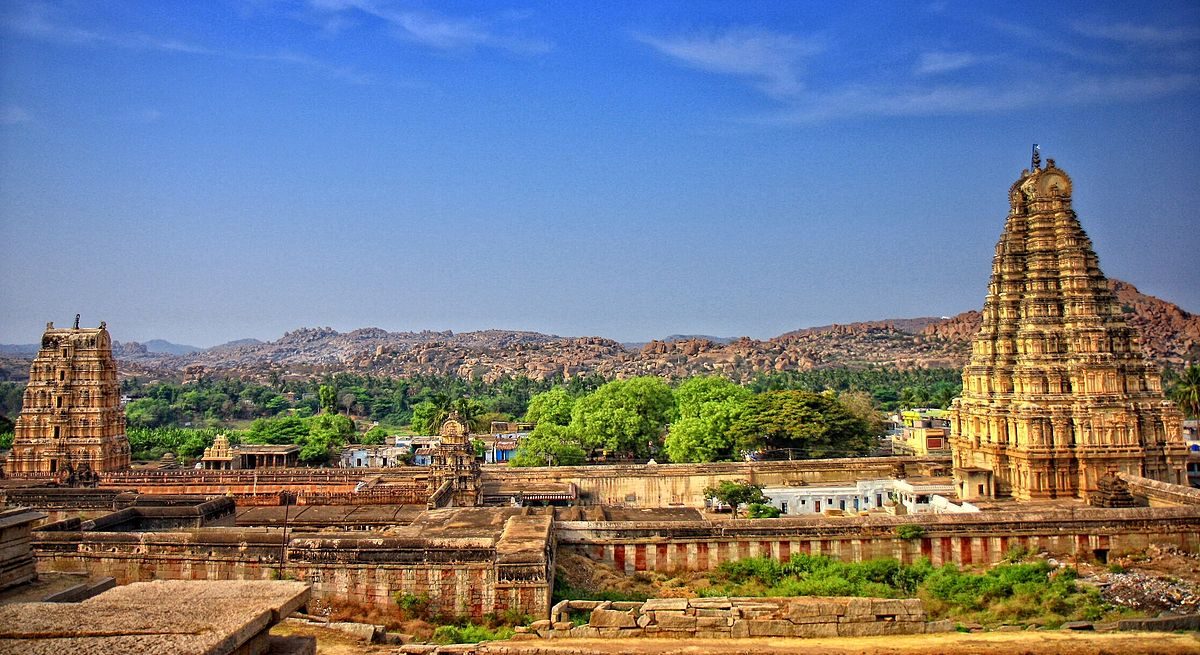If the temple could speak, what stories might it tell? If the Virupaksha Temple could speak, it would tell stories of centuries of devotion, artistry, and resilience. It would recount the reign of kings and emperors who worshipped within its walls, the festivals and ceremonies that have brought throngs of devotees year after year, and the thriving markets that once surrounded it, bustling with traders and pilgrims. The temple would also share tales of the invasions and conflicts that it witnessed, yet survived, standing as a testament to the enduring faith and dedication of its worshippers. 